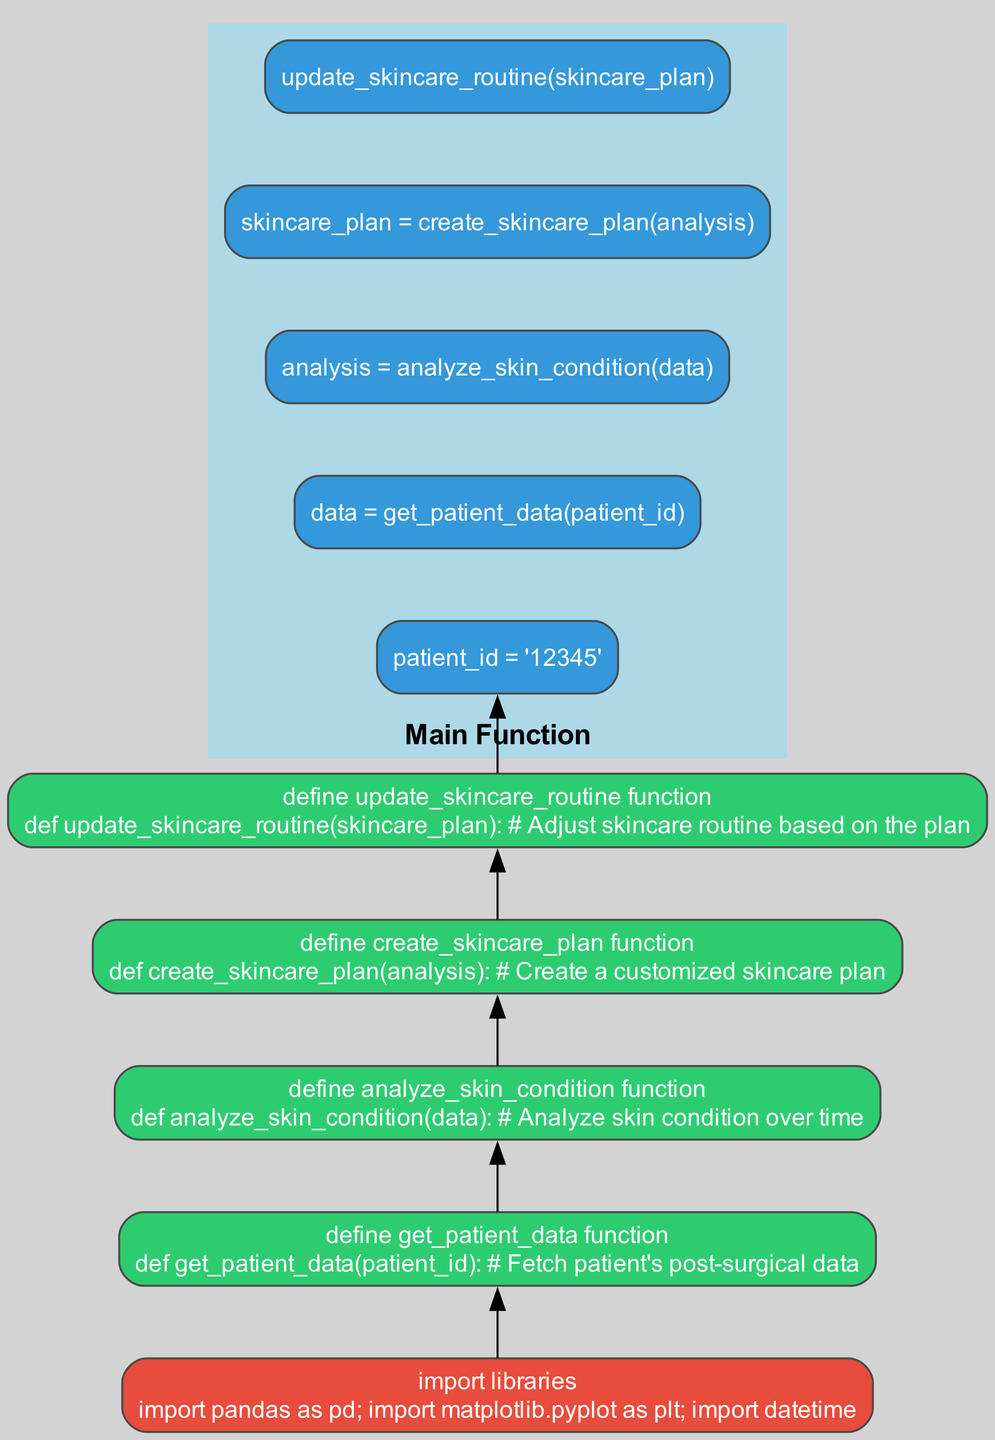what is the first step in the diagram? The first step in the workflow is to "import libraries," which is displayed at the bottom of the flowchart. This indicates the preparation required before any functions are defined or executed.
Answer: import libraries how many functions are defined in the diagram? There are four functions defined in the diagram: "get_patient_data," "analyze_skin_condition," "create_skincare_plan," and "update_skincare_routine." These are distinct function steps that follow the initial library import.
Answer: four what is the last function executed in the workflow? The last function to be executed in the workflow is "update_skincare_routine." It appears at the end of the flow leading from the "main function," indicating it is the final step of the process.
Answer: update_skincare_routine which function analyzes skin condition? The function that analyzes skin condition is "analyze_skin_condition," which follows the "get_patient_data" function in the workflow. This function takes the data retrieved from the patient and performs the analysis on it.
Answer: analyze_skin_condition what is the relationship between "define update_skincare_routine function" and "main function"? The relationship is that the "update_skincare_routine" function is the last step called by the "main function". This connection indicates that after the skincare plan is created, it is updated as part of the workflow.
Answer: last step called 